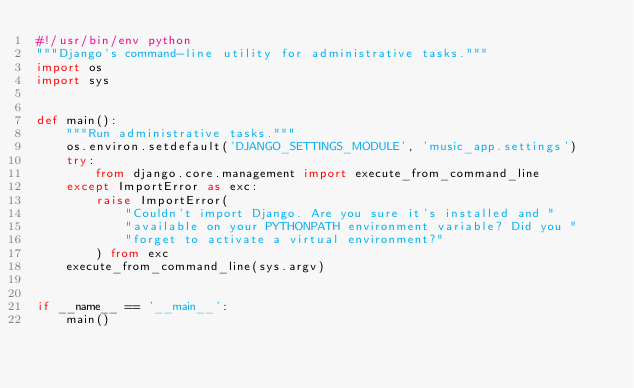Convert code to text. <code><loc_0><loc_0><loc_500><loc_500><_Python_>#!/usr/bin/env python
"""Django's command-line utility for administrative tasks."""
import os
import sys


def main():
    """Run administrative tasks."""
    os.environ.setdefault('DJANGO_SETTINGS_MODULE', 'music_app.settings')
    try:
        from django.core.management import execute_from_command_line
    except ImportError as exc:
        raise ImportError(
            "Couldn't import Django. Are you sure it's installed and "
            "available on your PYTHONPATH environment variable? Did you "
            "forget to activate a virtual environment?"
        ) from exc
    execute_from_command_line(sys.argv)


if __name__ == '__main__':
    main()
</code> 